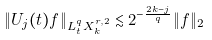Convert formula to latex. <formula><loc_0><loc_0><loc_500><loc_500>\| U _ { j } ( t ) f \| _ { L ^ { q } _ { t } X ^ { r , 2 } _ { k } } \lesssim 2 ^ { - \frac { 2 k - j } { q } } \| f \| _ { 2 }</formula> 